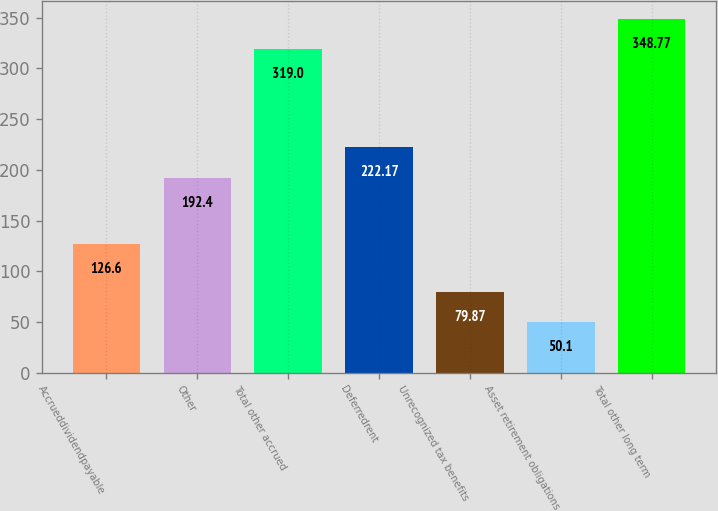<chart> <loc_0><loc_0><loc_500><loc_500><bar_chart><fcel>Accrueddividendpayable<fcel>Other<fcel>Total other accrued<fcel>Deferredrent<fcel>Unrecognized tax benefits<fcel>Asset retirement obligations<fcel>Total other long term<nl><fcel>126.6<fcel>192.4<fcel>319<fcel>222.17<fcel>79.87<fcel>50.1<fcel>348.77<nl></chart> 